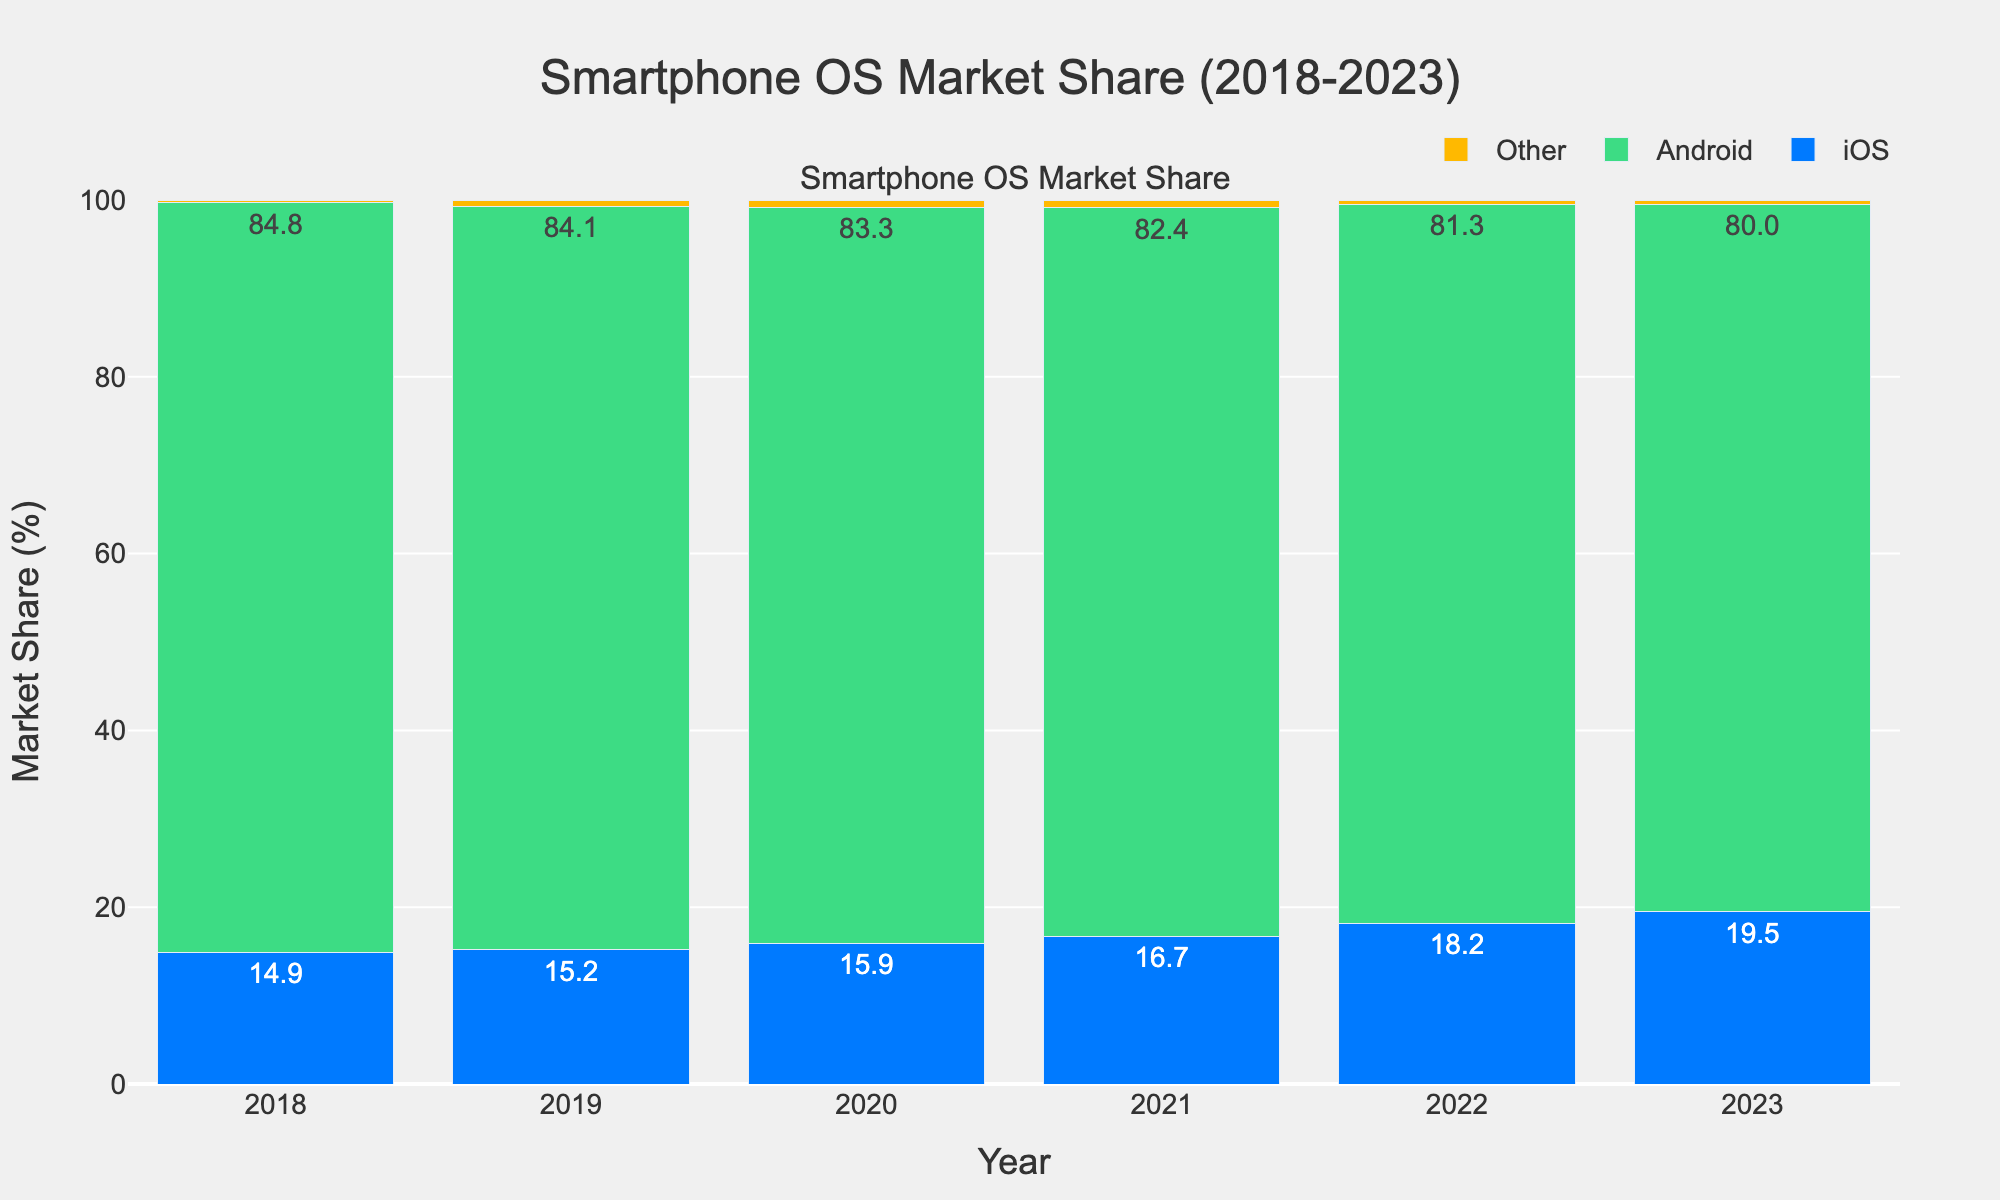What's the trend for iOS market share from 2018 to 2023? Look at the blue bars representing iOS market share for each year from 2018 to 2023. The heights of the bars show an increasing trend over time.
Answer: Increasing Which year had the highest market share for Android? Identify the tallest green bar among the years, representing the Android market share. The tallest bar is in 2018.
Answer: 2018 What's the total market share for "Other" operating systems over the six years? Sum the percentages of the "Other" category for each year: 0.3 + 0.7 + 0.8 + 0.9 + 0.5 + 0.5.
Answer: 3.7% In which year did iOS see the largest increase in market share compared to the previous year? Calculate the year-over-year difference for iOS and identify the largest increment: (2019-2018: 0.3, 2020-2019: 0.7, 2021-2020: 0.8, 2022-2021: 1.5, 2023-2022: 1.3). The largest increase is between 2021 and 2022 with 1.5%.
Answer: 2022 How does the market share of iOS in 2023 compare to Android in 2023? Look at the height of the blue bar (iOS) and the green bar (Android) for 2023. iOS is 19.5% and Android is 80.0%. Therefore, iOS is less than Android in 2023.
Answer: Less than What is the combined market share of iOS and Android in 2020? Add the iOS and Android market shares for 2020: 15.9 + 83.3.
Answer: 99.2% Which operating system group shows the most consistent market share over the observed years? Examine the variation in the bar heights for each group over the years. The "Other" category (yellow bars) shows the least variation compared to iOS and Android.
Answer: Other Between which years did the market share of Android drop the most significantly? Calculate the difference in market share for Android for consecutive years: (2019-2018: -0.7, 2020-2019: -0.8, 2021-2020: -0.9, 2022-2021: -1.1, 2023-2022: -1.3). The greatest drop is between 2022 and 2023.
Answer: 2022 and 2023 